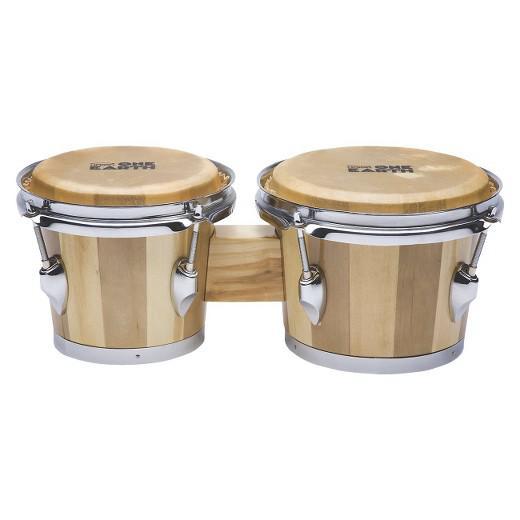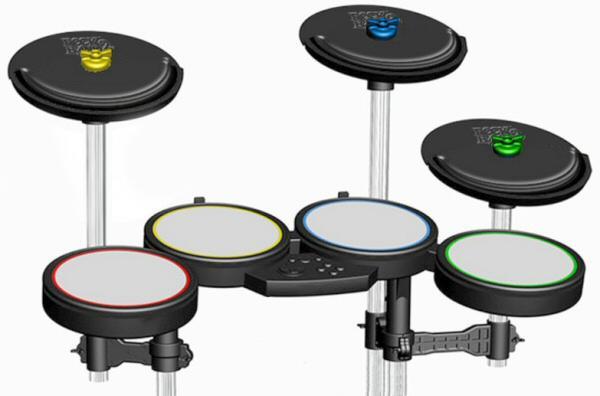The first image is the image on the left, the second image is the image on the right. Evaluate the accuracy of this statement regarding the images: "Each image contains one connected, side-by-side pair of drums with short feet on each drum, and one of the drum pairs is brown with multiple parallel lines encircling it.". Is it true? Answer yes or no. No. 